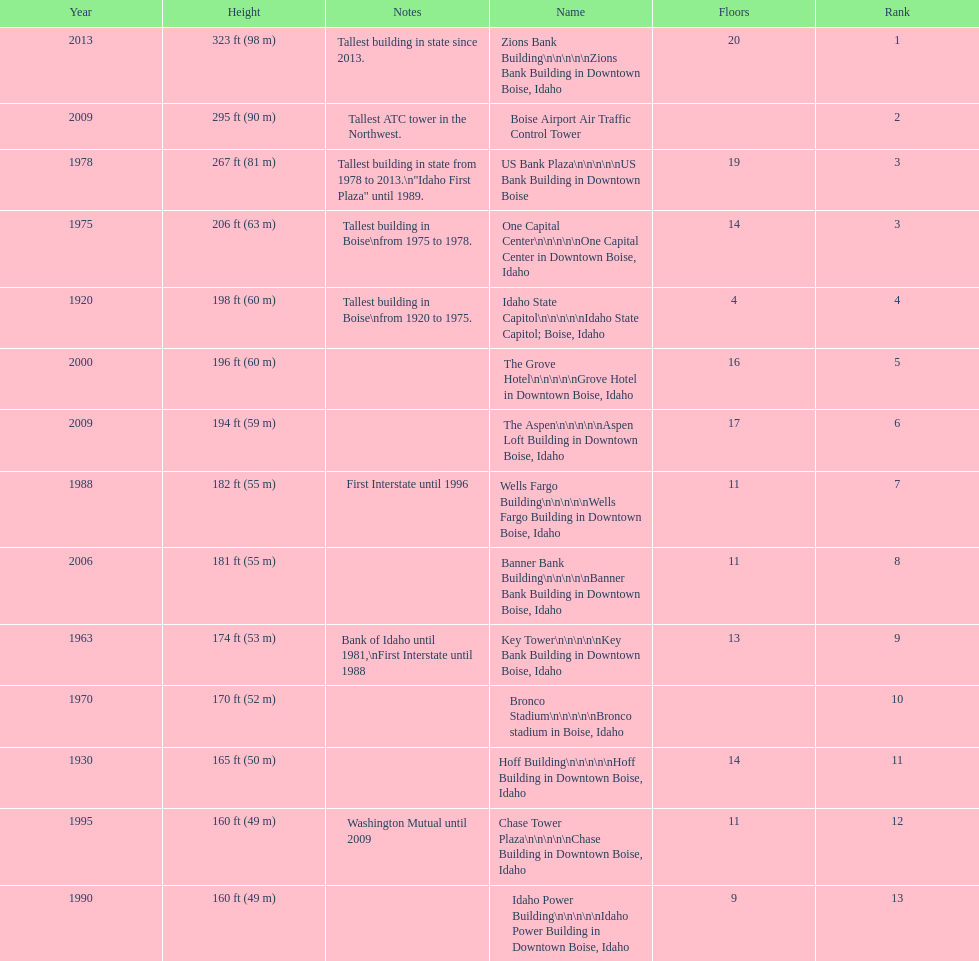What is the tallest building in bosie, idaho? Zions Bank Building Zions Bank Building in Downtown Boise, Idaho. 